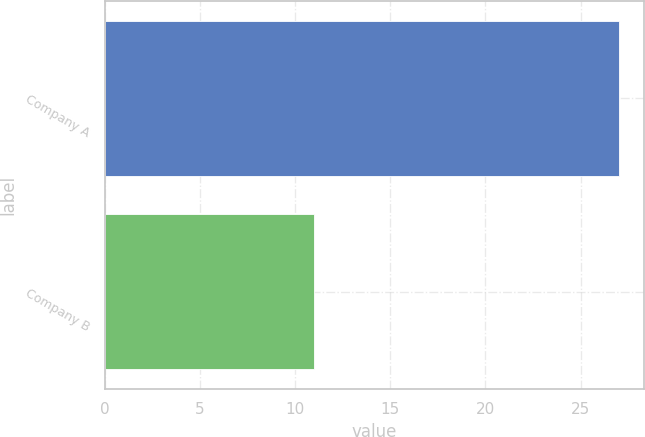Convert chart to OTSL. <chart><loc_0><loc_0><loc_500><loc_500><bar_chart><fcel>Company A<fcel>Company B<nl><fcel>27<fcel>11<nl></chart> 